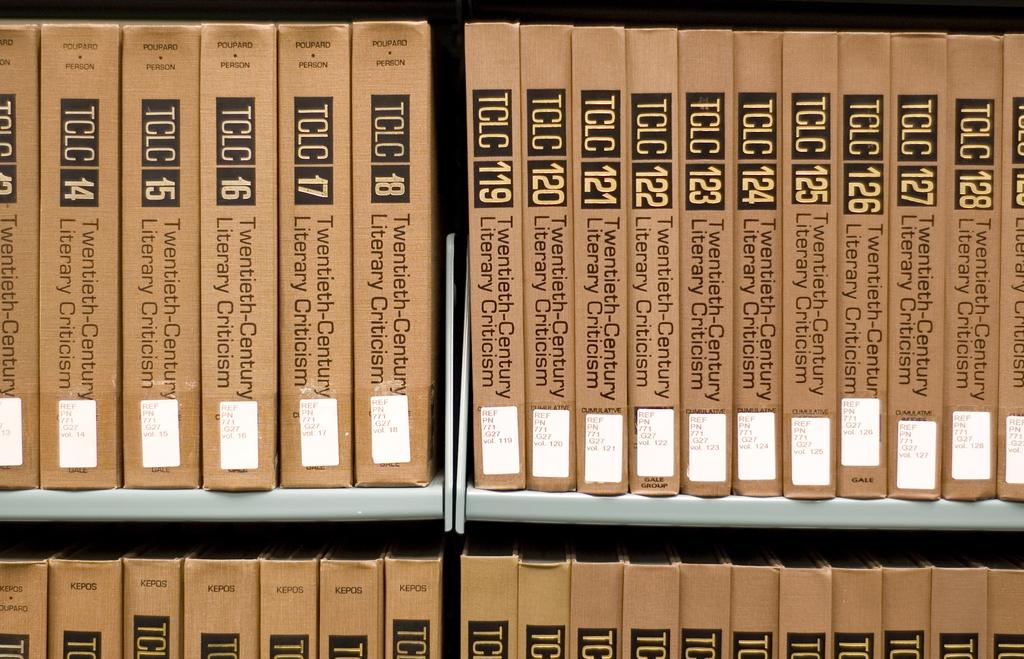<image>
Summarize the visual content of the image. some books with the numbers 123 on it 